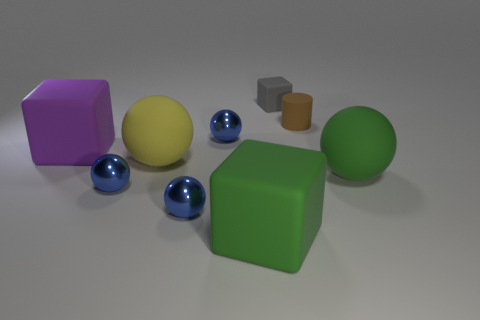Subtract all green cylinders. How many blue spheres are left? 3 Subtract 2 spheres. How many spheres are left? 3 Subtract all large matte balls. How many balls are left? 3 Subtract all green balls. How many balls are left? 4 Subtract all brown spheres. Subtract all red cylinders. How many spheres are left? 5 Add 1 big yellow cylinders. How many objects exist? 10 Subtract all spheres. How many objects are left? 4 Subtract 0 red balls. How many objects are left? 9 Subtract all big rubber things. Subtract all tiny blue shiny things. How many objects are left? 2 Add 2 big green blocks. How many big green blocks are left? 3 